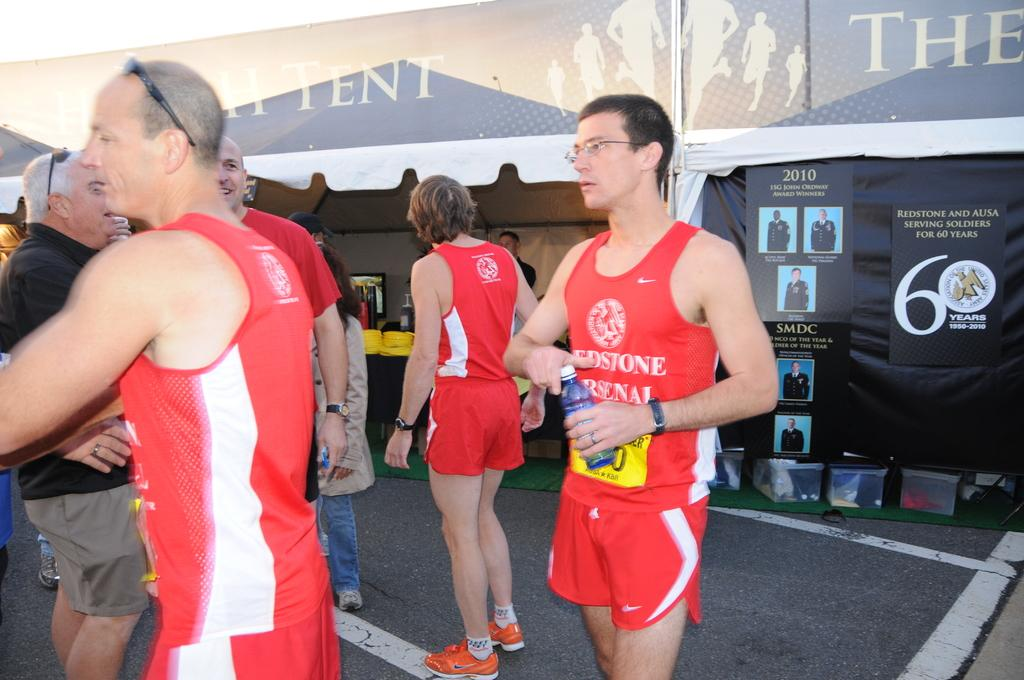<image>
Present a compact description of the photo's key features. Some men in red shorts and sleeveless vests one which the word Arsenal can be seen. 